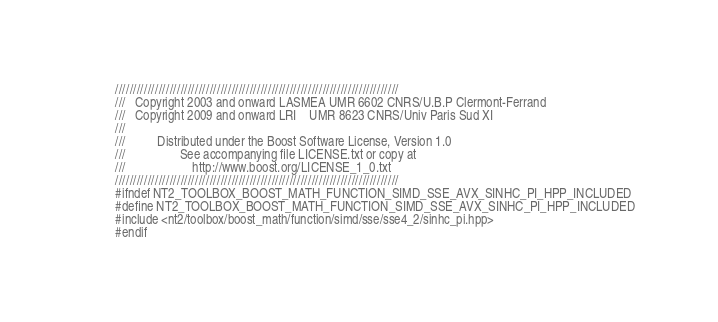Convert code to text. <code><loc_0><loc_0><loc_500><loc_500><_C++_>//////////////////////////////////////////////////////////////////////////////
///   Copyright 2003 and onward LASMEA UMR 6602 CNRS/U.B.P Clermont-Ferrand
///   Copyright 2009 and onward LRI    UMR 8623 CNRS/Univ Paris Sud XI
///
///          Distributed under the Boost Software License, Version 1.0
///                 See accompanying file LICENSE.txt or copy at
///                     http://www.boost.org/LICENSE_1_0.txt
//////////////////////////////////////////////////////////////////////////////
#ifndef NT2_TOOLBOX_BOOST_MATH_FUNCTION_SIMD_SSE_AVX_SINHC_PI_HPP_INCLUDED
#define NT2_TOOLBOX_BOOST_MATH_FUNCTION_SIMD_SSE_AVX_SINHC_PI_HPP_INCLUDED
#include <nt2/toolbox/boost_math/function/simd/sse/sse4_2/sinhc_pi.hpp>
#endif
</code> 